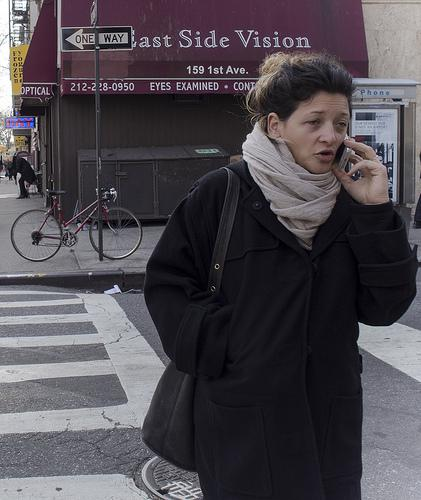Question: what is on the sign?
Choices:
A. Stop.
B. Grafitti.
C. Blue and white no parking symbol.
D. Words.
Answer with the letter. Answer: D Question: who is talking?
Choices:
A. The woman.
B. The man.
C. The child.
D. The baby.
Answer with the letter. Answer: A Question: what is she wearing?
Choices:
A. Dress.
B. Jeans.
C. Jacket.
D. Sweatpants.
Answer with the letter. Answer: C Question: what is behind her?
Choices:
A. Bike.
B. Mirror.
C. Beach.
D. Boat.
Answer with the letter. Answer: A 